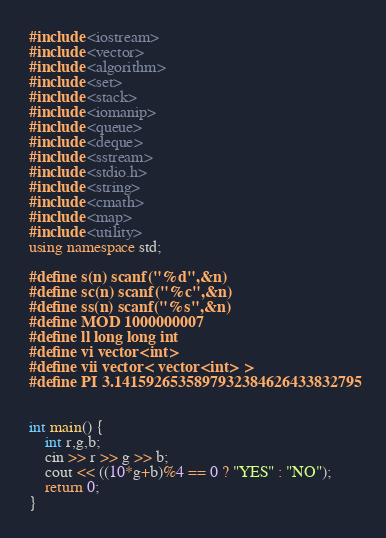<code> <loc_0><loc_0><loc_500><loc_500><_C++_>#include <iostream>
#include <vector>
#include <algorithm>
#include <set>
#include <stack>
#include <iomanip>
#include <queue>
#include <deque>
#include <sstream>
#include <stdio.h>
#include <string>
#include <cmath>
#include <map>
#include <utility>
using namespace std;

#define s(n) scanf("%d",&n)
#define sc(n) scanf("%c",&n)
#define ss(n) scanf("%s",&n)
#define MOD 1000000007
#define ll long long int
#define vi vector<int>
#define vii vector< vector<int> >
#define PI 3.1415926535897932384626433832795


int main() {
	int r,g,b;
	cin >> r >> g >> b;
	cout << ((10*g+b)%4 == 0 ? "YES" : "NO");
	return 0;
}

</code> 